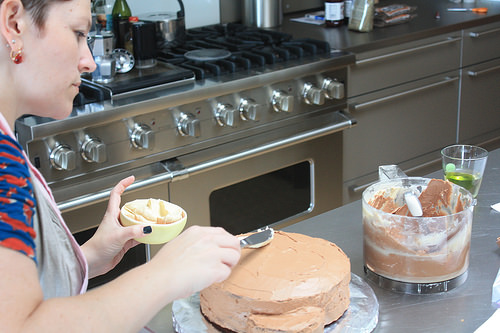<image>
Is there a cake on the table? Yes. Looking at the image, I can see the cake is positioned on top of the table, with the table providing support. Is there a stove behind the cake? Yes. From this viewpoint, the stove is positioned behind the cake, with the cake partially or fully occluding the stove. Is there a stove behind the glass? No. The stove is not behind the glass. From this viewpoint, the stove appears to be positioned elsewhere in the scene. Is there a utensil in the bowl? Yes. The utensil is contained within or inside the bowl, showing a containment relationship. Is the cup above the cake? No. The cup is not positioned above the cake. The vertical arrangement shows a different relationship. 